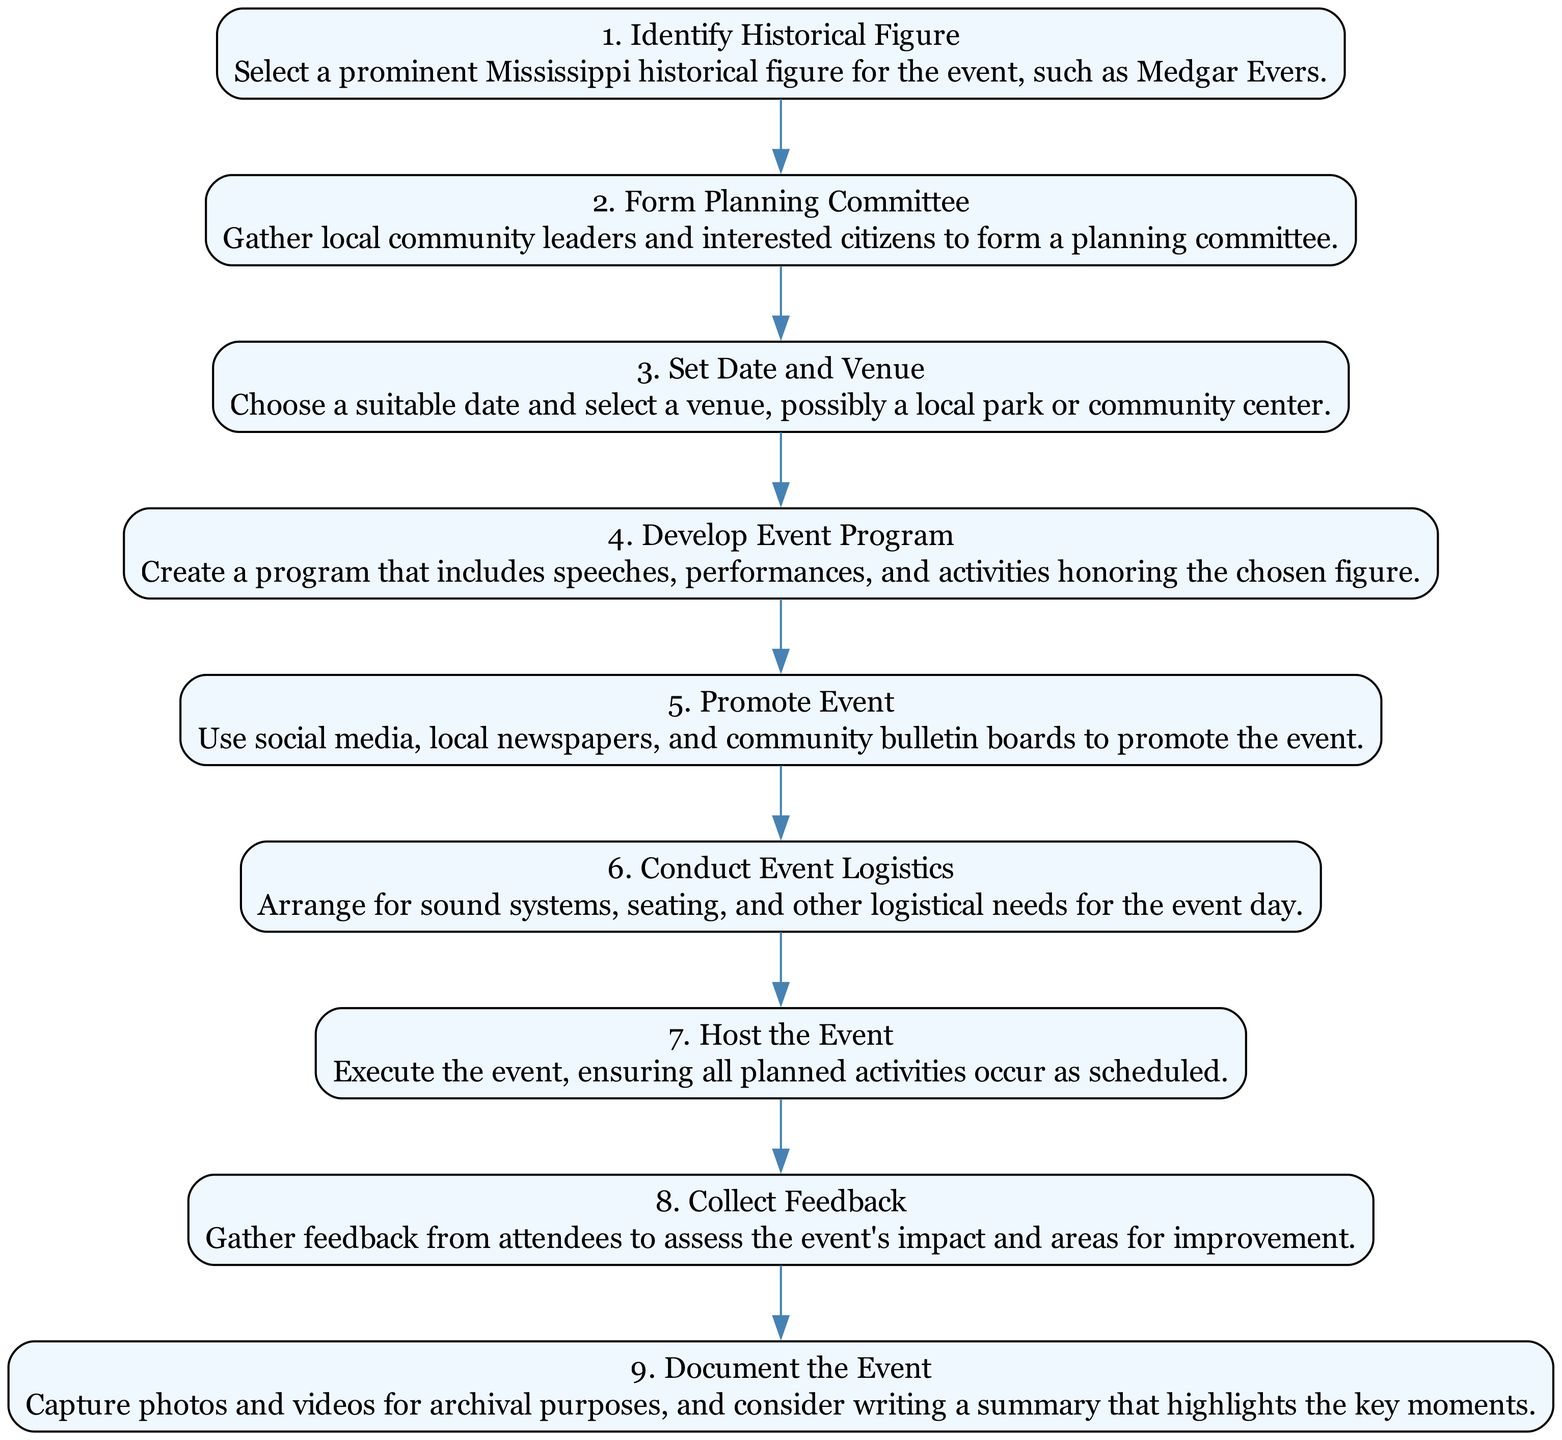What is the first step in organizing the event? The diagram indicates that the first step is "Identify Historical Figure," which means selecting a prominent Mississippi historical figure.
Answer: Identify Historical Figure How many nodes are depicted in the diagram? By counting each step listed in the diagram, we see there are nine distinct actions or nodes represented.
Answer: 9 What are the last two steps in the event organization process? The last two steps are "Collect Feedback" and "Document the Event," indicating what happens after the event takes place.
Answer: Collect Feedback and Document the Event What step follows "Set Date and Venue"? From the diagram’s flow, after "Set Date and Venue," the next step is "Develop Event Program." This indicates the chronological order of the planning process.
Answer: Develop Event Program Which step involves promoting the event? In the sequence, the step specifically focused on promotion is labeled "Promote Event," demonstrating the need for community outreach to ensure attendee participation.
Answer: Promote Event What is the direct relationship between "Conduct Event Logistics" and "Host the Event"? The diagram shows that "Conduct Event Logistics" directly precedes "Host the Event," indicating that logistics must be arranged before executing the event.
Answer: Conduct Event Logistics directly precedes Host the Event Which node describes gathering community leaders? The node that describes gathering community leaders is "Form Planning Committee," as this step involves organizing interested citizens in leadership roles.
Answer: Form Planning Committee How many steps are between "Develop Event Program" and "Host the Event"? There are three steps between these two actions: "Promote Event," "Conduct Event Logistics," and then "Host the Event." These steps highlight the preparation needed before the event takes place.
Answer: 3 What key action takes place immediately after the event occurs? The immediate action following the event, as described in the diagram, is "Collect Feedback," which relates to evaluating the event's impact.
Answer: Collect Feedback 